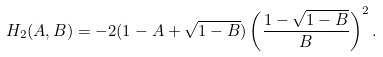<formula> <loc_0><loc_0><loc_500><loc_500>H _ { 2 } ( A , B ) = - 2 ( 1 - A + \sqrt { 1 - B } ) \left ( \frac { 1 - \sqrt { 1 - B } } { B } \right ) ^ { 2 } .</formula> 